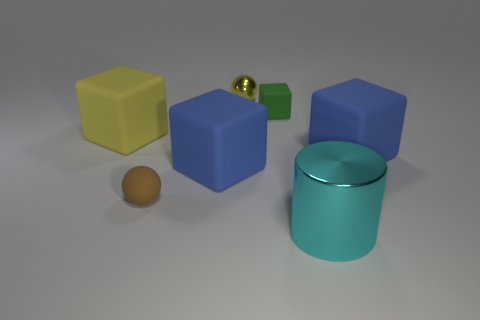Subtract all tiny blocks. How many blocks are left? 3 Subtract all blue blocks. How many blocks are left? 2 Subtract 1 spheres. How many spheres are left? 1 Add 3 green rubber cubes. How many objects exist? 10 Subtract all cylinders. How many objects are left? 6 Subtract all cyan balls. Subtract all yellow blocks. How many balls are left? 2 Subtract all gray cylinders. How many blue blocks are left? 2 Add 1 large red cylinders. How many large red cylinders exist? 1 Subtract 0 purple cubes. How many objects are left? 7 Subtract all big blue blocks. Subtract all tiny brown rubber things. How many objects are left? 4 